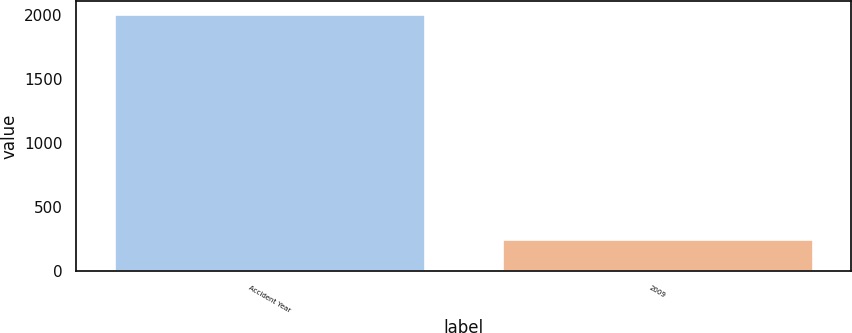<chart> <loc_0><loc_0><loc_500><loc_500><bar_chart><fcel>Accident Year<fcel>2009<nl><fcel>2013<fcel>256<nl></chart> 